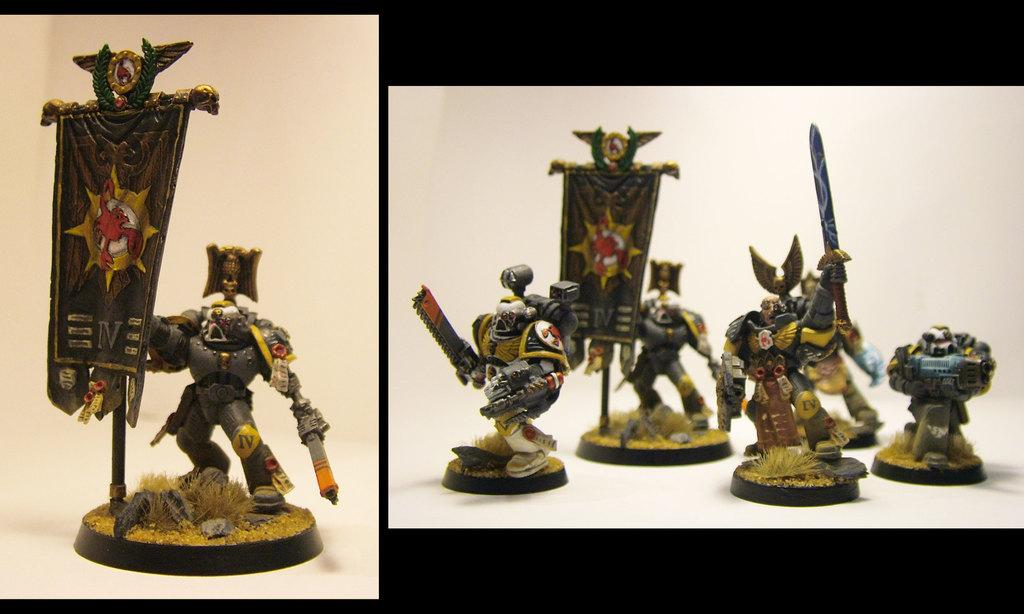What is the main subject of the image? There is a collage in the image. What types of items can be seen in the collage? There are toys, a flag, and a knife in the collage. Are there any other objects present in the collage? Yes, there are other objects in the collage. What type of memory is being used to store the collage in the image? The image does not provide information about the type of memory being used to store the collage. Can you describe the ground on which the collage is placed in the image? The image does not show the ground or any surface on which the collage is placed. 